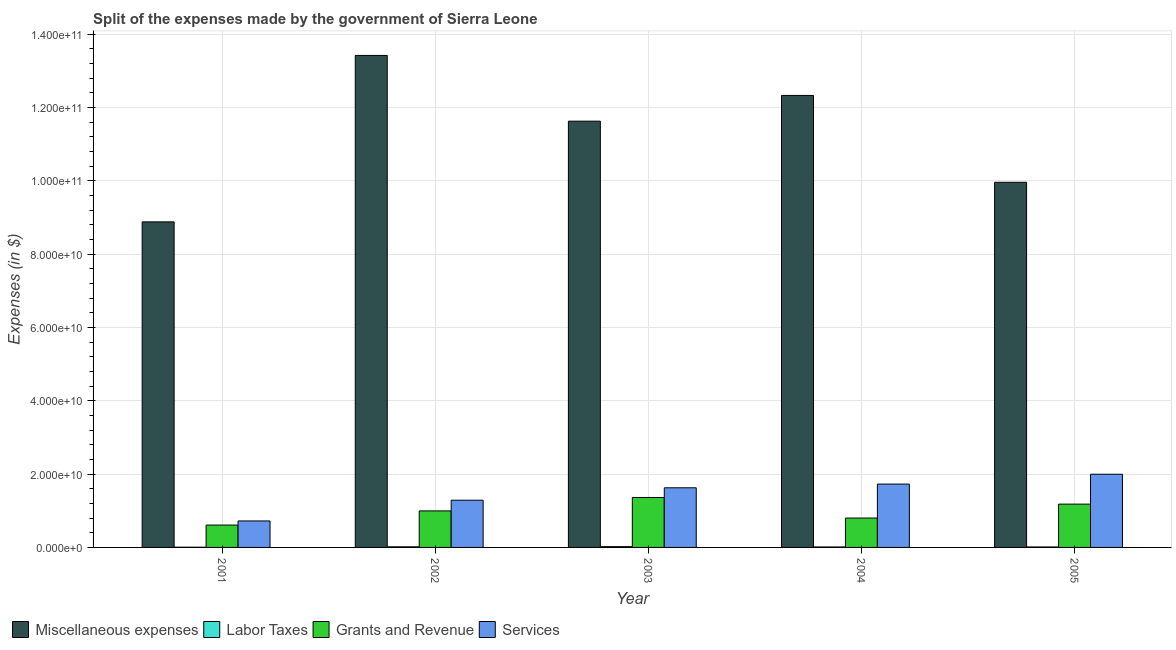How many groups of bars are there?
Ensure brevity in your answer.  5. Are the number of bars on each tick of the X-axis equal?
Keep it short and to the point. Yes. How many bars are there on the 3rd tick from the left?
Offer a very short reply. 4. How many bars are there on the 5th tick from the right?
Your answer should be very brief. 4. In how many cases, is the number of bars for a given year not equal to the number of legend labels?
Offer a terse response. 0. What is the amount spent on services in 2003?
Make the answer very short. 1.63e+1. Across all years, what is the maximum amount spent on grants and revenue?
Ensure brevity in your answer.  1.36e+1. Across all years, what is the minimum amount spent on grants and revenue?
Provide a succinct answer. 6.10e+09. In which year was the amount spent on services minimum?
Provide a succinct answer. 2001. What is the total amount spent on labor taxes in the graph?
Offer a very short reply. 6.82e+08. What is the difference between the amount spent on miscellaneous expenses in 2001 and that in 2004?
Ensure brevity in your answer.  -3.45e+1. What is the difference between the amount spent on grants and revenue in 2004 and the amount spent on miscellaneous expenses in 2001?
Provide a succinct answer. 1.92e+09. What is the average amount spent on labor taxes per year?
Your answer should be very brief. 1.36e+08. In the year 2004, what is the difference between the amount spent on services and amount spent on grants and revenue?
Ensure brevity in your answer.  0. What is the ratio of the amount spent on labor taxes in 2001 to that in 2004?
Offer a very short reply. 0.45. What is the difference between the highest and the second highest amount spent on services?
Offer a terse response. 2.69e+09. What is the difference between the highest and the lowest amount spent on services?
Offer a very short reply. 1.27e+1. In how many years, is the amount spent on labor taxes greater than the average amount spent on labor taxes taken over all years?
Offer a terse response. 2. What does the 3rd bar from the left in 2005 represents?
Provide a short and direct response. Grants and Revenue. What does the 4th bar from the right in 2001 represents?
Keep it short and to the point. Miscellaneous expenses. Is it the case that in every year, the sum of the amount spent on miscellaneous expenses and amount spent on labor taxes is greater than the amount spent on grants and revenue?
Offer a terse response. Yes. Are all the bars in the graph horizontal?
Provide a succinct answer. No. What is the difference between two consecutive major ticks on the Y-axis?
Offer a terse response. 2.00e+1. Are the values on the major ticks of Y-axis written in scientific E-notation?
Provide a succinct answer. Yes. Does the graph contain any zero values?
Make the answer very short. No. Does the graph contain grids?
Your answer should be very brief. Yes. Where does the legend appear in the graph?
Ensure brevity in your answer.  Bottom left. What is the title of the graph?
Provide a short and direct response. Split of the expenses made by the government of Sierra Leone. Does "Oil" appear as one of the legend labels in the graph?
Ensure brevity in your answer.  No. What is the label or title of the Y-axis?
Your answer should be compact. Expenses (in $). What is the Expenses (in $) in Miscellaneous expenses in 2001?
Provide a short and direct response. 8.88e+1. What is the Expenses (in $) of Labor Taxes in 2001?
Offer a terse response. 5.40e+07. What is the Expenses (in $) of Grants and Revenue in 2001?
Your answer should be compact. 6.10e+09. What is the Expenses (in $) of Services in 2001?
Your response must be concise. 7.22e+09. What is the Expenses (in $) of Miscellaneous expenses in 2002?
Your answer should be compact. 1.34e+11. What is the Expenses (in $) of Labor Taxes in 2002?
Offer a terse response. 1.65e+08. What is the Expenses (in $) in Grants and Revenue in 2002?
Provide a succinct answer. 9.96e+09. What is the Expenses (in $) of Services in 2002?
Your response must be concise. 1.29e+1. What is the Expenses (in $) in Miscellaneous expenses in 2003?
Your response must be concise. 1.16e+11. What is the Expenses (in $) of Labor Taxes in 2003?
Keep it short and to the point. 2.13e+08. What is the Expenses (in $) in Grants and Revenue in 2003?
Offer a very short reply. 1.36e+1. What is the Expenses (in $) of Services in 2003?
Provide a succinct answer. 1.63e+1. What is the Expenses (in $) in Miscellaneous expenses in 2004?
Your response must be concise. 1.23e+11. What is the Expenses (in $) of Labor Taxes in 2004?
Provide a short and direct response. 1.21e+08. What is the Expenses (in $) of Grants and Revenue in 2004?
Provide a succinct answer. 8.02e+09. What is the Expenses (in $) of Services in 2004?
Ensure brevity in your answer.  1.73e+1. What is the Expenses (in $) in Miscellaneous expenses in 2005?
Offer a terse response. 9.96e+1. What is the Expenses (in $) in Labor Taxes in 2005?
Offer a terse response. 1.29e+08. What is the Expenses (in $) of Grants and Revenue in 2005?
Make the answer very short. 1.18e+1. What is the Expenses (in $) of Services in 2005?
Keep it short and to the point. 2.00e+1. Across all years, what is the maximum Expenses (in $) of Miscellaneous expenses?
Your response must be concise. 1.34e+11. Across all years, what is the maximum Expenses (in $) in Labor Taxes?
Your answer should be compact. 2.13e+08. Across all years, what is the maximum Expenses (in $) of Grants and Revenue?
Make the answer very short. 1.36e+1. Across all years, what is the maximum Expenses (in $) of Services?
Give a very brief answer. 2.00e+1. Across all years, what is the minimum Expenses (in $) of Miscellaneous expenses?
Keep it short and to the point. 8.88e+1. Across all years, what is the minimum Expenses (in $) in Labor Taxes?
Ensure brevity in your answer.  5.40e+07. Across all years, what is the minimum Expenses (in $) in Grants and Revenue?
Make the answer very short. 6.10e+09. Across all years, what is the minimum Expenses (in $) in Services?
Your answer should be compact. 7.22e+09. What is the total Expenses (in $) in Miscellaneous expenses in the graph?
Offer a terse response. 5.62e+11. What is the total Expenses (in $) in Labor Taxes in the graph?
Your answer should be very brief. 6.82e+08. What is the total Expenses (in $) in Grants and Revenue in the graph?
Provide a succinct answer. 4.95e+1. What is the total Expenses (in $) of Services in the graph?
Offer a terse response. 7.36e+1. What is the difference between the Expenses (in $) in Miscellaneous expenses in 2001 and that in 2002?
Provide a succinct answer. -4.54e+1. What is the difference between the Expenses (in $) of Labor Taxes in 2001 and that in 2002?
Offer a terse response. -1.11e+08. What is the difference between the Expenses (in $) of Grants and Revenue in 2001 and that in 2002?
Provide a short and direct response. -3.87e+09. What is the difference between the Expenses (in $) in Services in 2001 and that in 2002?
Give a very brief answer. -5.66e+09. What is the difference between the Expenses (in $) in Miscellaneous expenses in 2001 and that in 2003?
Keep it short and to the point. -2.75e+1. What is the difference between the Expenses (in $) of Labor Taxes in 2001 and that in 2003?
Give a very brief answer. -1.59e+08. What is the difference between the Expenses (in $) of Grants and Revenue in 2001 and that in 2003?
Offer a very short reply. -7.53e+09. What is the difference between the Expenses (in $) of Services in 2001 and that in 2003?
Ensure brevity in your answer.  -9.04e+09. What is the difference between the Expenses (in $) of Miscellaneous expenses in 2001 and that in 2004?
Give a very brief answer. -3.45e+1. What is the difference between the Expenses (in $) in Labor Taxes in 2001 and that in 2004?
Provide a short and direct response. -6.70e+07. What is the difference between the Expenses (in $) in Grants and Revenue in 2001 and that in 2004?
Offer a very short reply. -1.92e+09. What is the difference between the Expenses (in $) of Services in 2001 and that in 2004?
Make the answer very short. -1.01e+1. What is the difference between the Expenses (in $) in Miscellaneous expenses in 2001 and that in 2005?
Provide a succinct answer. -1.08e+1. What is the difference between the Expenses (in $) in Labor Taxes in 2001 and that in 2005?
Give a very brief answer. -7.50e+07. What is the difference between the Expenses (in $) in Grants and Revenue in 2001 and that in 2005?
Give a very brief answer. -5.72e+09. What is the difference between the Expenses (in $) of Services in 2001 and that in 2005?
Make the answer very short. -1.27e+1. What is the difference between the Expenses (in $) of Miscellaneous expenses in 2002 and that in 2003?
Keep it short and to the point. 1.79e+1. What is the difference between the Expenses (in $) in Labor Taxes in 2002 and that in 2003?
Make the answer very short. -4.80e+07. What is the difference between the Expenses (in $) of Grants and Revenue in 2002 and that in 2003?
Your response must be concise. -3.66e+09. What is the difference between the Expenses (in $) of Services in 2002 and that in 2003?
Ensure brevity in your answer.  -3.39e+09. What is the difference between the Expenses (in $) in Miscellaneous expenses in 2002 and that in 2004?
Give a very brief answer. 1.09e+1. What is the difference between the Expenses (in $) in Labor Taxes in 2002 and that in 2004?
Your answer should be very brief. 4.40e+07. What is the difference between the Expenses (in $) of Grants and Revenue in 2002 and that in 2004?
Provide a short and direct response. 1.95e+09. What is the difference between the Expenses (in $) of Services in 2002 and that in 2004?
Keep it short and to the point. -4.40e+09. What is the difference between the Expenses (in $) of Miscellaneous expenses in 2002 and that in 2005?
Keep it short and to the point. 3.46e+1. What is the difference between the Expenses (in $) in Labor Taxes in 2002 and that in 2005?
Your answer should be compact. 3.60e+07. What is the difference between the Expenses (in $) of Grants and Revenue in 2002 and that in 2005?
Your answer should be compact. -1.85e+09. What is the difference between the Expenses (in $) of Services in 2002 and that in 2005?
Offer a terse response. -7.09e+09. What is the difference between the Expenses (in $) of Miscellaneous expenses in 2003 and that in 2004?
Offer a terse response. -7.02e+09. What is the difference between the Expenses (in $) of Labor Taxes in 2003 and that in 2004?
Provide a short and direct response. 9.20e+07. What is the difference between the Expenses (in $) in Grants and Revenue in 2003 and that in 2004?
Your response must be concise. 5.61e+09. What is the difference between the Expenses (in $) of Services in 2003 and that in 2004?
Your response must be concise. -1.01e+09. What is the difference between the Expenses (in $) in Miscellaneous expenses in 2003 and that in 2005?
Your response must be concise. 1.67e+1. What is the difference between the Expenses (in $) in Labor Taxes in 2003 and that in 2005?
Your answer should be compact. 8.40e+07. What is the difference between the Expenses (in $) of Grants and Revenue in 2003 and that in 2005?
Provide a short and direct response. 1.81e+09. What is the difference between the Expenses (in $) of Services in 2003 and that in 2005?
Offer a terse response. -3.70e+09. What is the difference between the Expenses (in $) of Miscellaneous expenses in 2004 and that in 2005?
Offer a very short reply. 2.37e+1. What is the difference between the Expenses (in $) of Labor Taxes in 2004 and that in 2005?
Provide a short and direct response. -8.00e+06. What is the difference between the Expenses (in $) in Grants and Revenue in 2004 and that in 2005?
Give a very brief answer. -3.80e+09. What is the difference between the Expenses (in $) in Services in 2004 and that in 2005?
Give a very brief answer. -2.69e+09. What is the difference between the Expenses (in $) of Miscellaneous expenses in 2001 and the Expenses (in $) of Labor Taxes in 2002?
Give a very brief answer. 8.86e+1. What is the difference between the Expenses (in $) in Miscellaneous expenses in 2001 and the Expenses (in $) in Grants and Revenue in 2002?
Make the answer very short. 7.88e+1. What is the difference between the Expenses (in $) of Miscellaneous expenses in 2001 and the Expenses (in $) of Services in 2002?
Your answer should be very brief. 7.59e+1. What is the difference between the Expenses (in $) of Labor Taxes in 2001 and the Expenses (in $) of Grants and Revenue in 2002?
Give a very brief answer. -9.91e+09. What is the difference between the Expenses (in $) of Labor Taxes in 2001 and the Expenses (in $) of Services in 2002?
Provide a succinct answer. -1.28e+1. What is the difference between the Expenses (in $) in Grants and Revenue in 2001 and the Expenses (in $) in Services in 2002?
Give a very brief answer. -6.78e+09. What is the difference between the Expenses (in $) in Miscellaneous expenses in 2001 and the Expenses (in $) in Labor Taxes in 2003?
Offer a very short reply. 8.86e+1. What is the difference between the Expenses (in $) in Miscellaneous expenses in 2001 and the Expenses (in $) in Grants and Revenue in 2003?
Offer a very short reply. 7.52e+1. What is the difference between the Expenses (in $) in Miscellaneous expenses in 2001 and the Expenses (in $) in Services in 2003?
Your answer should be very brief. 7.25e+1. What is the difference between the Expenses (in $) in Labor Taxes in 2001 and the Expenses (in $) in Grants and Revenue in 2003?
Provide a short and direct response. -1.36e+1. What is the difference between the Expenses (in $) of Labor Taxes in 2001 and the Expenses (in $) of Services in 2003?
Make the answer very short. -1.62e+1. What is the difference between the Expenses (in $) of Grants and Revenue in 2001 and the Expenses (in $) of Services in 2003?
Provide a short and direct response. -1.02e+1. What is the difference between the Expenses (in $) of Miscellaneous expenses in 2001 and the Expenses (in $) of Labor Taxes in 2004?
Your answer should be compact. 8.87e+1. What is the difference between the Expenses (in $) of Miscellaneous expenses in 2001 and the Expenses (in $) of Grants and Revenue in 2004?
Provide a short and direct response. 8.08e+1. What is the difference between the Expenses (in $) in Miscellaneous expenses in 2001 and the Expenses (in $) in Services in 2004?
Offer a terse response. 7.15e+1. What is the difference between the Expenses (in $) in Labor Taxes in 2001 and the Expenses (in $) in Grants and Revenue in 2004?
Your answer should be very brief. -7.96e+09. What is the difference between the Expenses (in $) in Labor Taxes in 2001 and the Expenses (in $) in Services in 2004?
Ensure brevity in your answer.  -1.72e+1. What is the difference between the Expenses (in $) in Grants and Revenue in 2001 and the Expenses (in $) in Services in 2004?
Provide a succinct answer. -1.12e+1. What is the difference between the Expenses (in $) in Miscellaneous expenses in 2001 and the Expenses (in $) in Labor Taxes in 2005?
Your response must be concise. 8.87e+1. What is the difference between the Expenses (in $) of Miscellaneous expenses in 2001 and the Expenses (in $) of Grants and Revenue in 2005?
Make the answer very short. 7.70e+1. What is the difference between the Expenses (in $) of Miscellaneous expenses in 2001 and the Expenses (in $) of Services in 2005?
Provide a succinct answer. 6.88e+1. What is the difference between the Expenses (in $) of Labor Taxes in 2001 and the Expenses (in $) of Grants and Revenue in 2005?
Keep it short and to the point. -1.18e+1. What is the difference between the Expenses (in $) of Labor Taxes in 2001 and the Expenses (in $) of Services in 2005?
Your answer should be very brief. -1.99e+1. What is the difference between the Expenses (in $) of Grants and Revenue in 2001 and the Expenses (in $) of Services in 2005?
Offer a terse response. -1.39e+1. What is the difference between the Expenses (in $) of Miscellaneous expenses in 2002 and the Expenses (in $) of Labor Taxes in 2003?
Offer a terse response. 1.34e+11. What is the difference between the Expenses (in $) of Miscellaneous expenses in 2002 and the Expenses (in $) of Grants and Revenue in 2003?
Provide a short and direct response. 1.21e+11. What is the difference between the Expenses (in $) in Miscellaneous expenses in 2002 and the Expenses (in $) in Services in 2003?
Your answer should be compact. 1.18e+11. What is the difference between the Expenses (in $) in Labor Taxes in 2002 and the Expenses (in $) in Grants and Revenue in 2003?
Provide a short and direct response. -1.35e+1. What is the difference between the Expenses (in $) in Labor Taxes in 2002 and the Expenses (in $) in Services in 2003?
Provide a short and direct response. -1.61e+1. What is the difference between the Expenses (in $) in Grants and Revenue in 2002 and the Expenses (in $) in Services in 2003?
Your response must be concise. -6.30e+09. What is the difference between the Expenses (in $) in Miscellaneous expenses in 2002 and the Expenses (in $) in Labor Taxes in 2004?
Your response must be concise. 1.34e+11. What is the difference between the Expenses (in $) of Miscellaneous expenses in 2002 and the Expenses (in $) of Grants and Revenue in 2004?
Ensure brevity in your answer.  1.26e+11. What is the difference between the Expenses (in $) of Miscellaneous expenses in 2002 and the Expenses (in $) of Services in 2004?
Ensure brevity in your answer.  1.17e+11. What is the difference between the Expenses (in $) in Labor Taxes in 2002 and the Expenses (in $) in Grants and Revenue in 2004?
Keep it short and to the point. -7.85e+09. What is the difference between the Expenses (in $) in Labor Taxes in 2002 and the Expenses (in $) in Services in 2004?
Provide a succinct answer. -1.71e+1. What is the difference between the Expenses (in $) of Grants and Revenue in 2002 and the Expenses (in $) of Services in 2004?
Provide a succinct answer. -7.31e+09. What is the difference between the Expenses (in $) in Miscellaneous expenses in 2002 and the Expenses (in $) in Labor Taxes in 2005?
Keep it short and to the point. 1.34e+11. What is the difference between the Expenses (in $) in Miscellaneous expenses in 2002 and the Expenses (in $) in Grants and Revenue in 2005?
Your answer should be very brief. 1.22e+11. What is the difference between the Expenses (in $) in Miscellaneous expenses in 2002 and the Expenses (in $) in Services in 2005?
Your answer should be compact. 1.14e+11. What is the difference between the Expenses (in $) in Labor Taxes in 2002 and the Expenses (in $) in Grants and Revenue in 2005?
Provide a short and direct response. -1.16e+1. What is the difference between the Expenses (in $) in Labor Taxes in 2002 and the Expenses (in $) in Services in 2005?
Give a very brief answer. -1.98e+1. What is the difference between the Expenses (in $) in Grants and Revenue in 2002 and the Expenses (in $) in Services in 2005?
Ensure brevity in your answer.  -1.00e+1. What is the difference between the Expenses (in $) of Miscellaneous expenses in 2003 and the Expenses (in $) of Labor Taxes in 2004?
Offer a terse response. 1.16e+11. What is the difference between the Expenses (in $) in Miscellaneous expenses in 2003 and the Expenses (in $) in Grants and Revenue in 2004?
Your answer should be very brief. 1.08e+11. What is the difference between the Expenses (in $) of Miscellaneous expenses in 2003 and the Expenses (in $) of Services in 2004?
Keep it short and to the point. 9.90e+1. What is the difference between the Expenses (in $) in Labor Taxes in 2003 and the Expenses (in $) in Grants and Revenue in 2004?
Your answer should be very brief. -7.80e+09. What is the difference between the Expenses (in $) in Labor Taxes in 2003 and the Expenses (in $) in Services in 2004?
Your answer should be compact. -1.71e+1. What is the difference between the Expenses (in $) of Grants and Revenue in 2003 and the Expenses (in $) of Services in 2004?
Offer a very short reply. -3.65e+09. What is the difference between the Expenses (in $) of Miscellaneous expenses in 2003 and the Expenses (in $) of Labor Taxes in 2005?
Ensure brevity in your answer.  1.16e+11. What is the difference between the Expenses (in $) in Miscellaneous expenses in 2003 and the Expenses (in $) in Grants and Revenue in 2005?
Provide a succinct answer. 1.04e+11. What is the difference between the Expenses (in $) in Miscellaneous expenses in 2003 and the Expenses (in $) in Services in 2005?
Offer a very short reply. 9.63e+1. What is the difference between the Expenses (in $) of Labor Taxes in 2003 and the Expenses (in $) of Grants and Revenue in 2005?
Make the answer very short. -1.16e+1. What is the difference between the Expenses (in $) of Labor Taxes in 2003 and the Expenses (in $) of Services in 2005?
Keep it short and to the point. -1.98e+1. What is the difference between the Expenses (in $) in Grants and Revenue in 2003 and the Expenses (in $) in Services in 2005?
Your answer should be very brief. -6.34e+09. What is the difference between the Expenses (in $) in Miscellaneous expenses in 2004 and the Expenses (in $) in Labor Taxes in 2005?
Offer a terse response. 1.23e+11. What is the difference between the Expenses (in $) of Miscellaneous expenses in 2004 and the Expenses (in $) of Grants and Revenue in 2005?
Your answer should be compact. 1.11e+11. What is the difference between the Expenses (in $) in Miscellaneous expenses in 2004 and the Expenses (in $) in Services in 2005?
Your answer should be very brief. 1.03e+11. What is the difference between the Expenses (in $) of Labor Taxes in 2004 and the Expenses (in $) of Grants and Revenue in 2005?
Give a very brief answer. -1.17e+1. What is the difference between the Expenses (in $) in Labor Taxes in 2004 and the Expenses (in $) in Services in 2005?
Provide a succinct answer. -1.98e+1. What is the difference between the Expenses (in $) of Grants and Revenue in 2004 and the Expenses (in $) of Services in 2005?
Your answer should be compact. -1.20e+1. What is the average Expenses (in $) in Miscellaneous expenses per year?
Ensure brevity in your answer.  1.12e+11. What is the average Expenses (in $) in Labor Taxes per year?
Offer a very short reply. 1.36e+08. What is the average Expenses (in $) of Grants and Revenue per year?
Offer a terse response. 9.90e+09. What is the average Expenses (in $) in Services per year?
Offer a terse response. 1.47e+1. In the year 2001, what is the difference between the Expenses (in $) in Miscellaneous expenses and Expenses (in $) in Labor Taxes?
Offer a very short reply. 8.87e+1. In the year 2001, what is the difference between the Expenses (in $) in Miscellaneous expenses and Expenses (in $) in Grants and Revenue?
Provide a short and direct response. 8.27e+1. In the year 2001, what is the difference between the Expenses (in $) of Miscellaneous expenses and Expenses (in $) of Services?
Offer a terse response. 8.16e+1. In the year 2001, what is the difference between the Expenses (in $) of Labor Taxes and Expenses (in $) of Grants and Revenue?
Give a very brief answer. -6.04e+09. In the year 2001, what is the difference between the Expenses (in $) in Labor Taxes and Expenses (in $) in Services?
Give a very brief answer. -7.17e+09. In the year 2001, what is the difference between the Expenses (in $) of Grants and Revenue and Expenses (in $) of Services?
Your answer should be very brief. -1.12e+09. In the year 2002, what is the difference between the Expenses (in $) of Miscellaneous expenses and Expenses (in $) of Labor Taxes?
Provide a succinct answer. 1.34e+11. In the year 2002, what is the difference between the Expenses (in $) of Miscellaneous expenses and Expenses (in $) of Grants and Revenue?
Keep it short and to the point. 1.24e+11. In the year 2002, what is the difference between the Expenses (in $) of Miscellaneous expenses and Expenses (in $) of Services?
Offer a terse response. 1.21e+11. In the year 2002, what is the difference between the Expenses (in $) in Labor Taxes and Expenses (in $) in Grants and Revenue?
Your response must be concise. -9.80e+09. In the year 2002, what is the difference between the Expenses (in $) in Labor Taxes and Expenses (in $) in Services?
Make the answer very short. -1.27e+1. In the year 2002, what is the difference between the Expenses (in $) in Grants and Revenue and Expenses (in $) in Services?
Keep it short and to the point. -2.92e+09. In the year 2003, what is the difference between the Expenses (in $) in Miscellaneous expenses and Expenses (in $) in Labor Taxes?
Your answer should be very brief. 1.16e+11. In the year 2003, what is the difference between the Expenses (in $) of Miscellaneous expenses and Expenses (in $) of Grants and Revenue?
Offer a very short reply. 1.03e+11. In the year 2003, what is the difference between the Expenses (in $) in Miscellaneous expenses and Expenses (in $) in Services?
Offer a very short reply. 1.00e+11. In the year 2003, what is the difference between the Expenses (in $) of Labor Taxes and Expenses (in $) of Grants and Revenue?
Your response must be concise. -1.34e+1. In the year 2003, what is the difference between the Expenses (in $) in Labor Taxes and Expenses (in $) in Services?
Your response must be concise. -1.61e+1. In the year 2003, what is the difference between the Expenses (in $) in Grants and Revenue and Expenses (in $) in Services?
Keep it short and to the point. -2.64e+09. In the year 2004, what is the difference between the Expenses (in $) in Miscellaneous expenses and Expenses (in $) in Labor Taxes?
Provide a short and direct response. 1.23e+11. In the year 2004, what is the difference between the Expenses (in $) of Miscellaneous expenses and Expenses (in $) of Grants and Revenue?
Offer a very short reply. 1.15e+11. In the year 2004, what is the difference between the Expenses (in $) in Miscellaneous expenses and Expenses (in $) in Services?
Make the answer very short. 1.06e+11. In the year 2004, what is the difference between the Expenses (in $) in Labor Taxes and Expenses (in $) in Grants and Revenue?
Ensure brevity in your answer.  -7.89e+09. In the year 2004, what is the difference between the Expenses (in $) in Labor Taxes and Expenses (in $) in Services?
Offer a terse response. -1.72e+1. In the year 2004, what is the difference between the Expenses (in $) in Grants and Revenue and Expenses (in $) in Services?
Offer a terse response. -9.26e+09. In the year 2005, what is the difference between the Expenses (in $) of Miscellaneous expenses and Expenses (in $) of Labor Taxes?
Offer a very short reply. 9.95e+1. In the year 2005, what is the difference between the Expenses (in $) in Miscellaneous expenses and Expenses (in $) in Grants and Revenue?
Offer a terse response. 8.78e+1. In the year 2005, what is the difference between the Expenses (in $) of Miscellaneous expenses and Expenses (in $) of Services?
Provide a short and direct response. 7.96e+1. In the year 2005, what is the difference between the Expenses (in $) of Labor Taxes and Expenses (in $) of Grants and Revenue?
Your response must be concise. -1.17e+1. In the year 2005, what is the difference between the Expenses (in $) in Labor Taxes and Expenses (in $) in Services?
Your answer should be very brief. -1.98e+1. In the year 2005, what is the difference between the Expenses (in $) in Grants and Revenue and Expenses (in $) in Services?
Provide a succinct answer. -8.15e+09. What is the ratio of the Expenses (in $) in Miscellaneous expenses in 2001 to that in 2002?
Provide a succinct answer. 0.66. What is the ratio of the Expenses (in $) of Labor Taxes in 2001 to that in 2002?
Make the answer very short. 0.33. What is the ratio of the Expenses (in $) of Grants and Revenue in 2001 to that in 2002?
Offer a very short reply. 0.61. What is the ratio of the Expenses (in $) in Services in 2001 to that in 2002?
Offer a terse response. 0.56. What is the ratio of the Expenses (in $) of Miscellaneous expenses in 2001 to that in 2003?
Make the answer very short. 0.76. What is the ratio of the Expenses (in $) in Labor Taxes in 2001 to that in 2003?
Your response must be concise. 0.25. What is the ratio of the Expenses (in $) in Grants and Revenue in 2001 to that in 2003?
Your answer should be compact. 0.45. What is the ratio of the Expenses (in $) in Services in 2001 to that in 2003?
Offer a very short reply. 0.44. What is the ratio of the Expenses (in $) in Miscellaneous expenses in 2001 to that in 2004?
Your response must be concise. 0.72. What is the ratio of the Expenses (in $) in Labor Taxes in 2001 to that in 2004?
Ensure brevity in your answer.  0.45. What is the ratio of the Expenses (in $) in Grants and Revenue in 2001 to that in 2004?
Offer a very short reply. 0.76. What is the ratio of the Expenses (in $) of Services in 2001 to that in 2004?
Ensure brevity in your answer.  0.42. What is the ratio of the Expenses (in $) in Miscellaneous expenses in 2001 to that in 2005?
Offer a terse response. 0.89. What is the ratio of the Expenses (in $) of Labor Taxes in 2001 to that in 2005?
Your answer should be compact. 0.42. What is the ratio of the Expenses (in $) of Grants and Revenue in 2001 to that in 2005?
Offer a very short reply. 0.52. What is the ratio of the Expenses (in $) in Services in 2001 to that in 2005?
Provide a short and direct response. 0.36. What is the ratio of the Expenses (in $) of Miscellaneous expenses in 2002 to that in 2003?
Ensure brevity in your answer.  1.15. What is the ratio of the Expenses (in $) of Labor Taxes in 2002 to that in 2003?
Your answer should be very brief. 0.77. What is the ratio of the Expenses (in $) of Grants and Revenue in 2002 to that in 2003?
Keep it short and to the point. 0.73. What is the ratio of the Expenses (in $) in Services in 2002 to that in 2003?
Your answer should be very brief. 0.79. What is the ratio of the Expenses (in $) in Miscellaneous expenses in 2002 to that in 2004?
Offer a terse response. 1.09. What is the ratio of the Expenses (in $) of Labor Taxes in 2002 to that in 2004?
Give a very brief answer. 1.36. What is the ratio of the Expenses (in $) of Grants and Revenue in 2002 to that in 2004?
Offer a very short reply. 1.24. What is the ratio of the Expenses (in $) in Services in 2002 to that in 2004?
Offer a terse response. 0.75. What is the ratio of the Expenses (in $) in Miscellaneous expenses in 2002 to that in 2005?
Your response must be concise. 1.35. What is the ratio of the Expenses (in $) in Labor Taxes in 2002 to that in 2005?
Ensure brevity in your answer.  1.28. What is the ratio of the Expenses (in $) of Grants and Revenue in 2002 to that in 2005?
Your response must be concise. 0.84. What is the ratio of the Expenses (in $) of Services in 2002 to that in 2005?
Your response must be concise. 0.65. What is the ratio of the Expenses (in $) in Miscellaneous expenses in 2003 to that in 2004?
Your answer should be compact. 0.94. What is the ratio of the Expenses (in $) of Labor Taxes in 2003 to that in 2004?
Give a very brief answer. 1.76. What is the ratio of the Expenses (in $) of Grants and Revenue in 2003 to that in 2004?
Your answer should be very brief. 1.7. What is the ratio of the Expenses (in $) in Services in 2003 to that in 2004?
Provide a succinct answer. 0.94. What is the ratio of the Expenses (in $) of Miscellaneous expenses in 2003 to that in 2005?
Provide a short and direct response. 1.17. What is the ratio of the Expenses (in $) in Labor Taxes in 2003 to that in 2005?
Ensure brevity in your answer.  1.65. What is the ratio of the Expenses (in $) in Grants and Revenue in 2003 to that in 2005?
Provide a short and direct response. 1.15. What is the ratio of the Expenses (in $) in Services in 2003 to that in 2005?
Your answer should be compact. 0.81. What is the ratio of the Expenses (in $) of Miscellaneous expenses in 2004 to that in 2005?
Provide a short and direct response. 1.24. What is the ratio of the Expenses (in $) in Labor Taxes in 2004 to that in 2005?
Keep it short and to the point. 0.94. What is the ratio of the Expenses (in $) of Grants and Revenue in 2004 to that in 2005?
Provide a succinct answer. 0.68. What is the ratio of the Expenses (in $) of Services in 2004 to that in 2005?
Offer a very short reply. 0.87. What is the difference between the highest and the second highest Expenses (in $) in Miscellaneous expenses?
Keep it short and to the point. 1.09e+1. What is the difference between the highest and the second highest Expenses (in $) in Labor Taxes?
Keep it short and to the point. 4.80e+07. What is the difference between the highest and the second highest Expenses (in $) in Grants and Revenue?
Keep it short and to the point. 1.81e+09. What is the difference between the highest and the second highest Expenses (in $) of Services?
Give a very brief answer. 2.69e+09. What is the difference between the highest and the lowest Expenses (in $) of Miscellaneous expenses?
Provide a short and direct response. 4.54e+1. What is the difference between the highest and the lowest Expenses (in $) of Labor Taxes?
Make the answer very short. 1.59e+08. What is the difference between the highest and the lowest Expenses (in $) of Grants and Revenue?
Give a very brief answer. 7.53e+09. What is the difference between the highest and the lowest Expenses (in $) of Services?
Your answer should be very brief. 1.27e+1. 